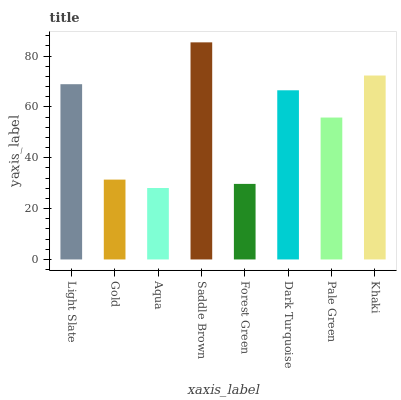Is Aqua the minimum?
Answer yes or no. Yes. Is Saddle Brown the maximum?
Answer yes or no. Yes. Is Gold the minimum?
Answer yes or no. No. Is Gold the maximum?
Answer yes or no. No. Is Light Slate greater than Gold?
Answer yes or no. Yes. Is Gold less than Light Slate?
Answer yes or no. Yes. Is Gold greater than Light Slate?
Answer yes or no. No. Is Light Slate less than Gold?
Answer yes or no. No. Is Dark Turquoise the high median?
Answer yes or no. Yes. Is Pale Green the low median?
Answer yes or no. Yes. Is Khaki the high median?
Answer yes or no. No. Is Light Slate the low median?
Answer yes or no. No. 